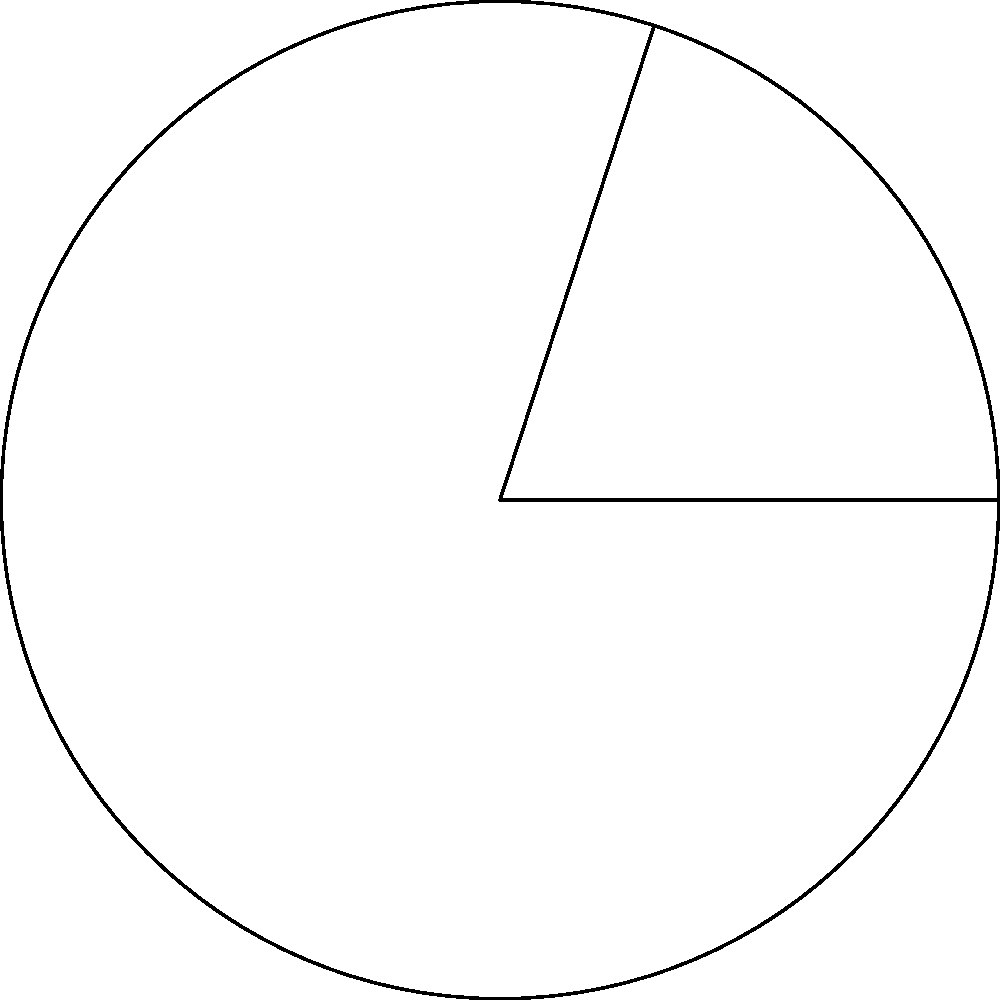As a social media influencer, you're tracking the engagement of your followers in a specific cause. The circle represents your total follower base, and the shaded sector represents those actively engaged. If the radius of the circle is 10 cm and the central angle of the sector is 72°, what percentage of your followers are engaged in the cause? (Round your answer to the nearest whole number.) To solve this problem, we'll follow these steps:

1) First, we need to calculate the area of the entire circle:
   Area of circle = $\pi r^2 = \pi (10\text{ cm})^2 = 100\pi \text{ cm}^2$

2) Next, we'll calculate the area of the sector:
   Area of sector = $\frac{\theta}{360°} \pi r^2$, where $\theta$ is the central angle in degrees
   Area of sector = $\frac{72°}{360°} \pi (10\text{ cm})^2 = 20\pi \text{ cm}^2$

3) To find the percentage, we divide the area of the sector by the area of the circle and multiply by 100:
   Percentage = $\frac{\text{Area of sector}}{\text{Area of circle}} \times 100\%$
               = $\frac{20\pi \text{ cm}^2}{100\pi \text{ cm}^2} \times 100\%$
               = $0.2 \times 100\% = 20\%$

4) Rounding to the nearest whole number, we get 20%.

Therefore, 20% of your followers are engaged in the specific cause.
Answer: 20% 